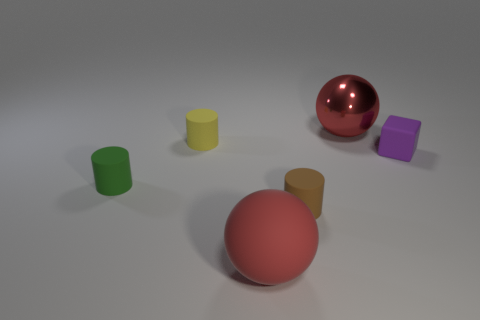If this image were part of an advertisement, what do you think it would be promoting, based on the items and their presentation? Based on the simplicity and playful arrangement of the objects, this image could be part of an advertisement for a children's educational playset, focusing on shapes and colors. Can you suggest a tagline for the supposed advertisement that reflects the playful and educational aspect of these objects? Explore and Learn: Dive into a world of colors and shapes where every playtime is a discovery! 